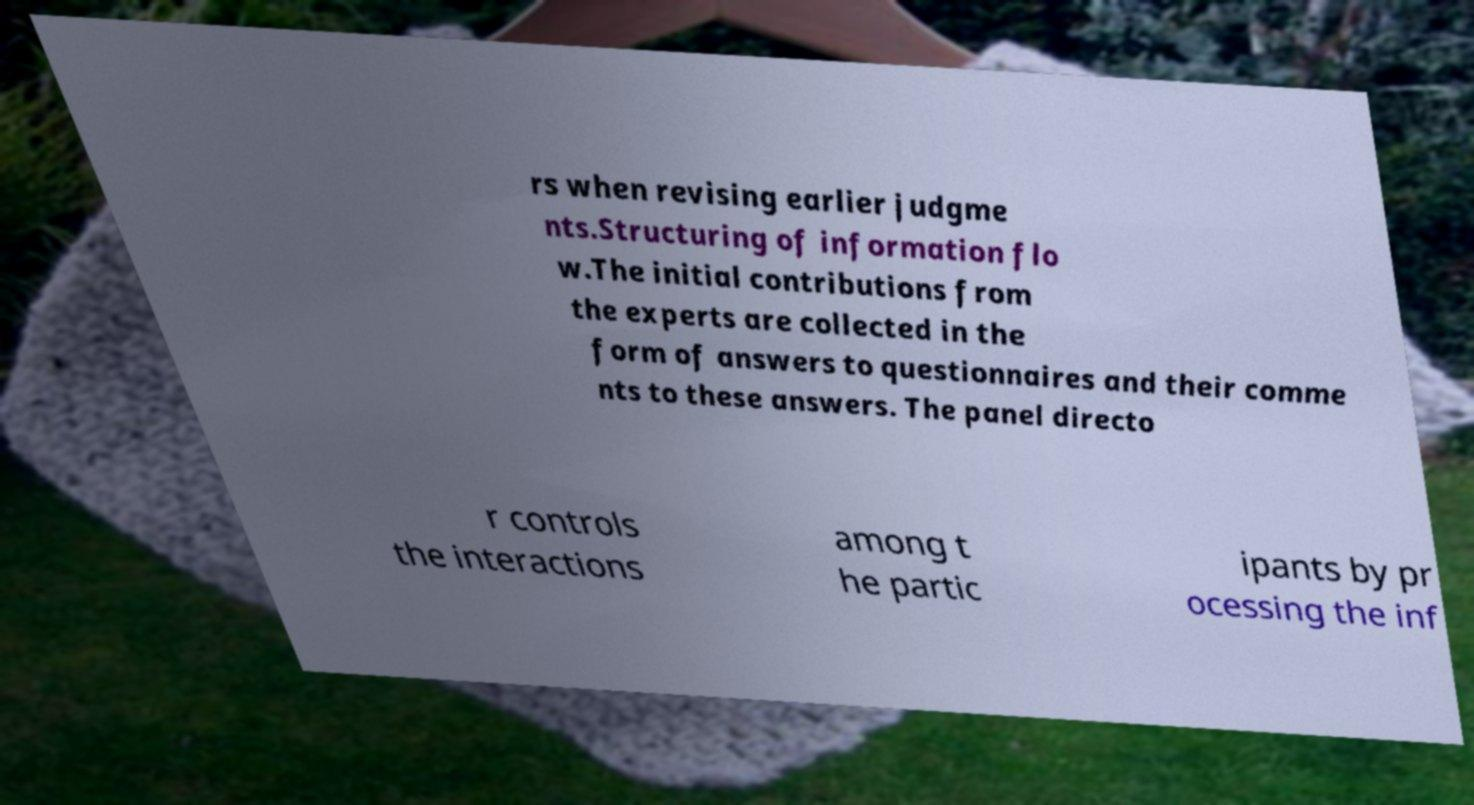There's text embedded in this image that I need extracted. Can you transcribe it verbatim? rs when revising earlier judgme nts.Structuring of information flo w.The initial contributions from the experts are collected in the form of answers to questionnaires and their comme nts to these answers. The panel directo r controls the interactions among t he partic ipants by pr ocessing the inf 